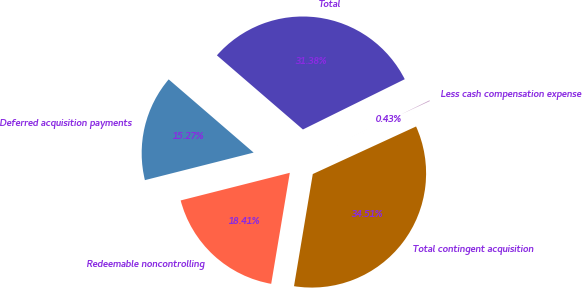Convert chart to OTSL. <chart><loc_0><loc_0><loc_500><loc_500><pie_chart><fcel>Deferred acquisition payments<fcel>Redeemable noncontrolling<fcel>Total contingent acquisition<fcel>Less cash compensation expense<fcel>Total<nl><fcel>15.27%<fcel>18.41%<fcel>34.51%<fcel>0.43%<fcel>31.38%<nl></chart> 